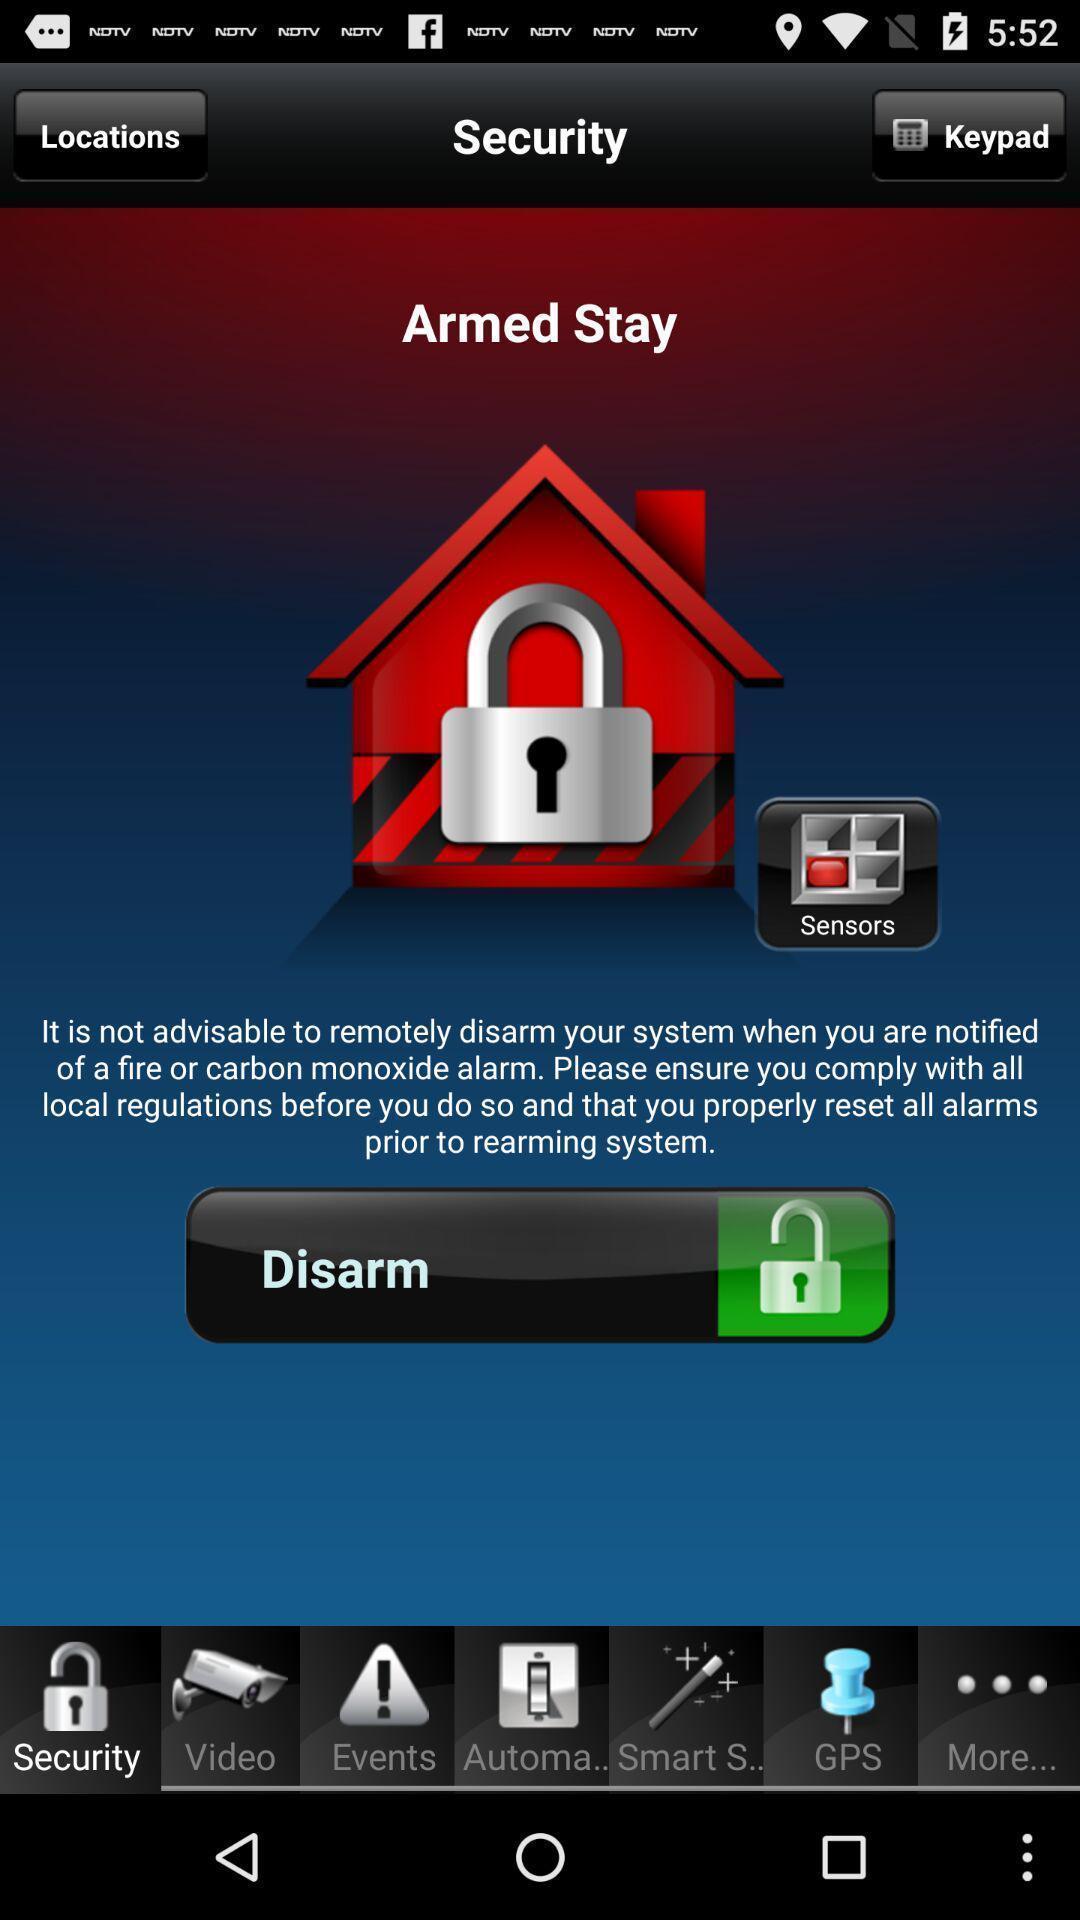Describe the visual elements of this screenshot. Security page. 